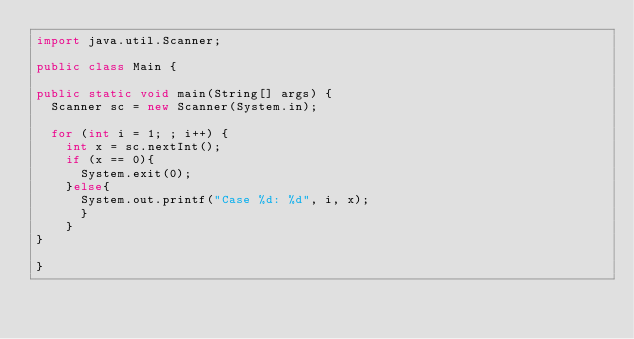Convert code to text. <code><loc_0><loc_0><loc_500><loc_500><_Java_>import java.util.Scanner;

public class Main {

public static void main(String[] args) {
	Scanner sc = new Scanner(System.in);
	
	for (int i = 1; ; i++) {
		int x = sc.nextInt();
		if (x == 0){
			System.exit(0);
		}else{
			System.out.printf("Case %d: %d", i, x);
			}
		}
}

}</code> 